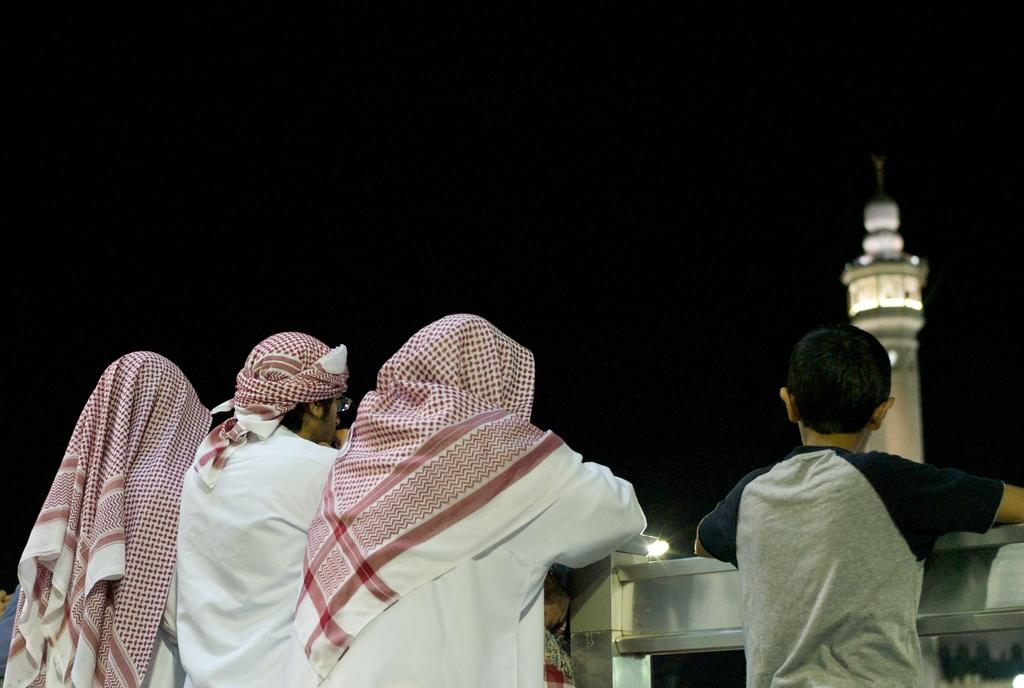How many people are in the image? There is a group of people in the image, but the exact number is not specified. What is in front of the people in the image? There is railing in front of the people in the image. What can be seen in the distance in the image? There is a tower visible in the image. What color is the background of the image? The background of the image is black. What type of attraction can be seen on the face of the tower in the image? There is no attraction visible on the face of the tower in the image. What type of war is being depicted in the image? There is no war being depicted in the image; it features a group of people, railing, a tower, and a black background. 